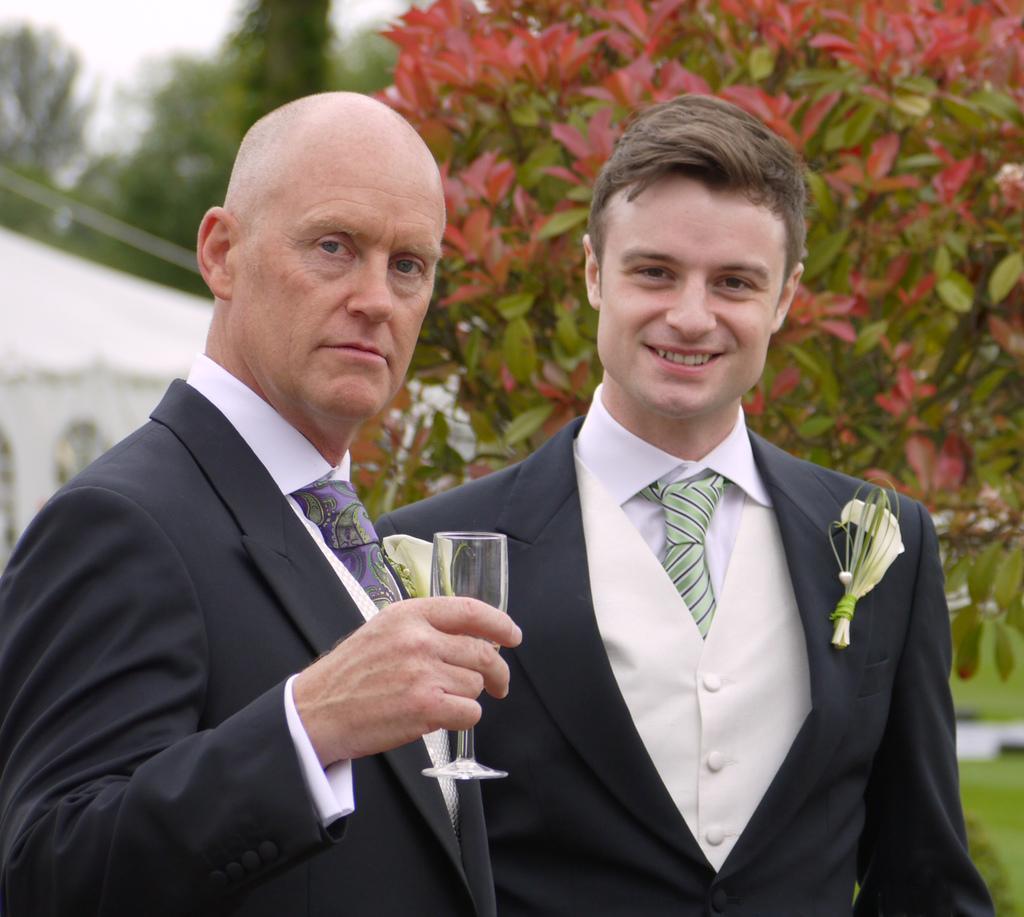Can you describe this image briefly? In the image there are two men standing. There is a man holding a glass in his hand. Behind them there are leaves. And also there is a blur background. 